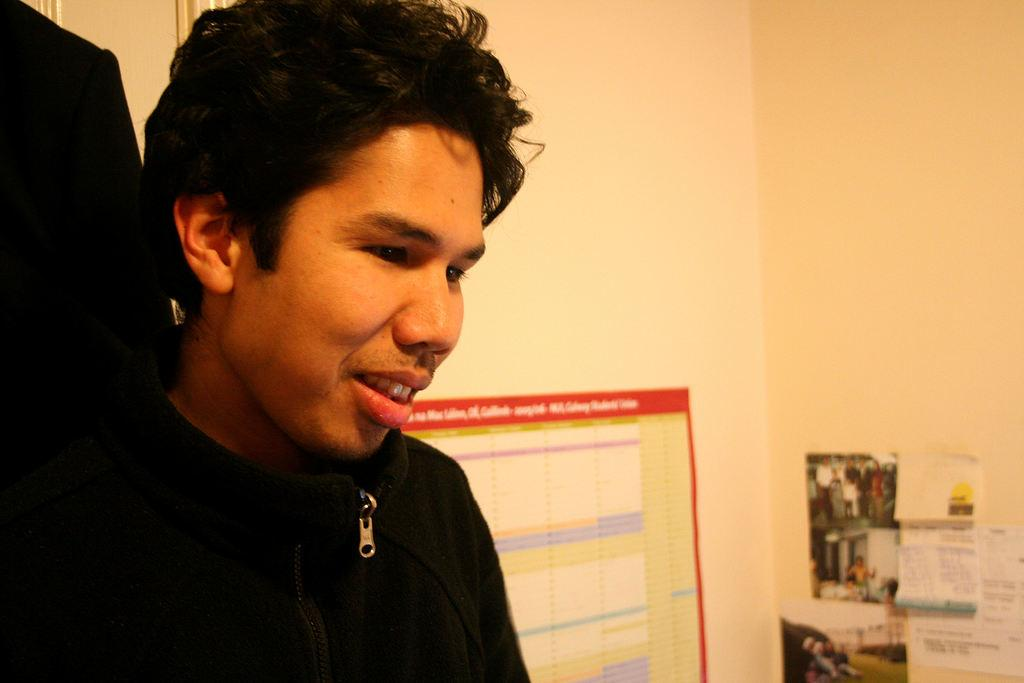What is the main subject in the image? There is a man standing in the image. What is behind the man in the image? There is a wall behind the man. What is on the wall in the image? A chart is sticked on the wall, and papers and pictures are sticked on the wall in the bottom right corner. How many lizards can be seen crawling on the wall in the image? There are no lizards visible in the image; the wall has a chart, papers, and pictures sticked on it. 